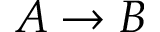<formula> <loc_0><loc_0><loc_500><loc_500>A \rightarrow B</formula> 